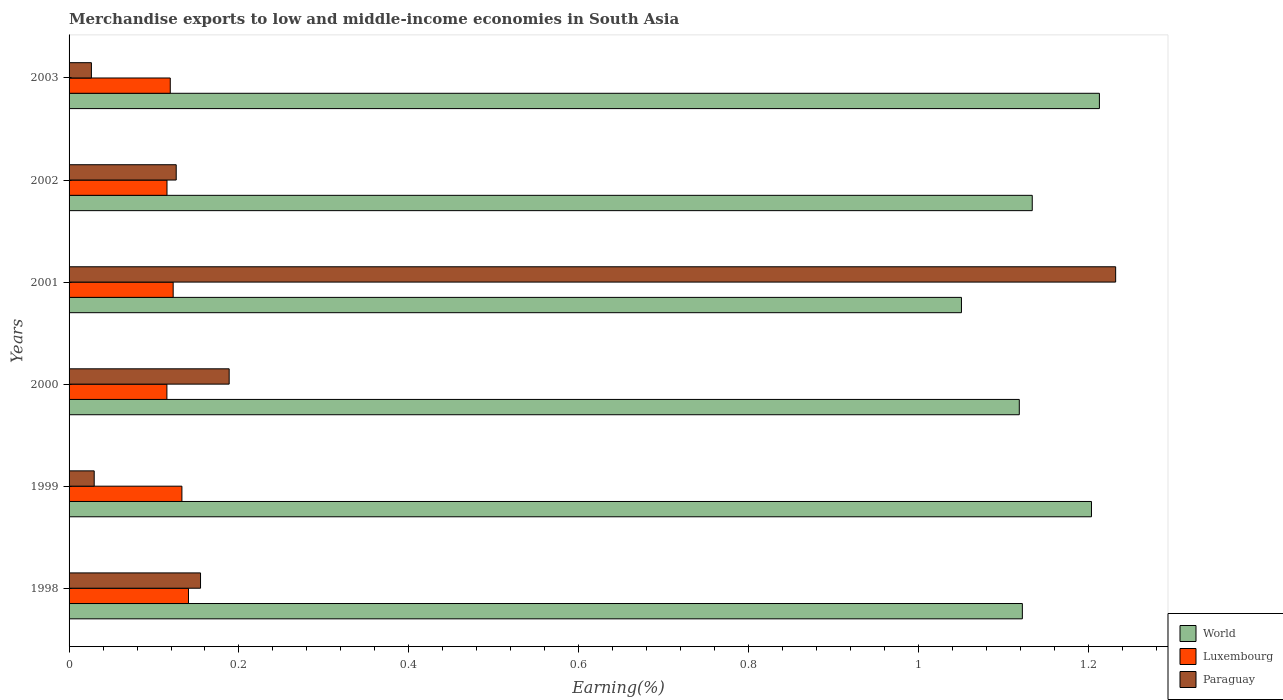How many different coloured bars are there?
Make the answer very short. 3. What is the label of the 2nd group of bars from the top?
Ensure brevity in your answer.  2002. In how many cases, is the number of bars for a given year not equal to the number of legend labels?
Provide a succinct answer. 0. What is the percentage of amount earned from merchandise exports in Paraguay in 2000?
Ensure brevity in your answer.  0.19. Across all years, what is the maximum percentage of amount earned from merchandise exports in World?
Provide a short and direct response. 1.21. Across all years, what is the minimum percentage of amount earned from merchandise exports in Paraguay?
Your response must be concise. 0.03. What is the total percentage of amount earned from merchandise exports in World in the graph?
Ensure brevity in your answer.  6.84. What is the difference between the percentage of amount earned from merchandise exports in Paraguay in 2000 and that in 2002?
Provide a short and direct response. 0.06. What is the difference between the percentage of amount earned from merchandise exports in Luxembourg in 2000 and the percentage of amount earned from merchandise exports in Paraguay in 2001?
Provide a short and direct response. -1.12. What is the average percentage of amount earned from merchandise exports in Paraguay per year?
Offer a terse response. 0.29. In the year 2001, what is the difference between the percentage of amount earned from merchandise exports in Paraguay and percentage of amount earned from merchandise exports in World?
Give a very brief answer. 0.18. In how many years, is the percentage of amount earned from merchandise exports in Paraguay greater than 0.16 %?
Your answer should be very brief. 2. What is the ratio of the percentage of amount earned from merchandise exports in Paraguay in 2002 to that in 2003?
Your answer should be very brief. 4.8. Is the percentage of amount earned from merchandise exports in World in 2001 less than that in 2002?
Offer a terse response. Yes. Is the difference between the percentage of amount earned from merchandise exports in Paraguay in 1999 and 2003 greater than the difference between the percentage of amount earned from merchandise exports in World in 1999 and 2003?
Provide a short and direct response. Yes. What is the difference between the highest and the second highest percentage of amount earned from merchandise exports in World?
Provide a short and direct response. 0.01. What is the difference between the highest and the lowest percentage of amount earned from merchandise exports in World?
Your response must be concise. 0.16. What does the 3rd bar from the top in 2002 represents?
Offer a terse response. World. What does the 2nd bar from the bottom in 2002 represents?
Make the answer very short. Luxembourg. Is it the case that in every year, the sum of the percentage of amount earned from merchandise exports in Paraguay and percentage of amount earned from merchandise exports in Luxembourg is greater than the percentage of amount earned from merchandise exports in World?
Offer a terse response. No. How many bars are there?
Your answer should be very brief. 18. Are all the bars in the graph horizontal?
Ensure brevity in your answer.  Yes. What is the difference between two consecutive major ticks on the X-axis?
Provide a succinct answer. 0.2. Are the values on the major ticks of X-axis written in scientific E-notation?
Provide a succinct answer. No. Where does the legend appear in the graph?
Your answer should be compact. Bottom right. What is the title of the graph?
Offer a terse response. Merchandise exports to low and middle-income economies in South Asia. Does "Saudi Arabia" appear as one of the legend labels in the graph?
Offer a terse response. No. What is the label or title of the X-axis?
Keep it short and to the point. Earning(%). What is the Earning(%) in World in 1998?
Provide a short and direct response. 1.12. What is the Earning(%) of Luxembourg in 1998?
Your response must be concise. 0.14. What is the Earning(%) of Paraguay in 1998?
Make the answer very short. 0.15. What is the Earning(%) in World in 1999?
Offer a very short reply. 1.2. What is the Earning(%) in Luxembourg in 1999?
Offer a terse response. 0.13. What is the Earning(%) of Paraguay in 1999?
Provide a succinct answer. 0.03. What is the Earning(%) in World in 2000?
Make the answer very short. 1.12. What is the Earning(%) in Luxembourg in 2000?
Ensure brevity in your answer.  0.12. What is the Earning(%) in Paraguay in 2000?
Give a very brief answer. 0.19. What is the Earning(%) in World in 2001?
Your answer should be compact. 1.05. What is the Earning(%) in Luxembourg in 2001?
Give a very brief answer. 0.12. What is the Earning(%) in Paraguay in 2001?
Your answer should be very brief. 1.23. What is the Earning(%) in World in 2002?
Keep it short and to the point. 1.13. What is the Earning(%) of Luxembourg in 2002?
Provide a succinct answer. 0.12. What is the Earning(%) in Paraguay in 2002?
Provide a succinct answer. 0.13. What is the Earning(%) of World in 2003?
Make the answer very short. 1.21. What is the Earning(%) in Luxembourg in 2003?
Keep it short and to the point. 0.12. What is the Earning(%) in Paraguay in 2003?
Ensure brevity in your answer.  0.03. Across all years, what is the maximum Earning(%) of World?
Keep it short and to the point. 1.21. Across all years, what is the maximum Earning(%) in Luxembourg?
Provide a succinct answer. 0.14. Across all years, what is the maximum Earning(%) in Paraguay?
Ensure brevity in your answer.  1.23. Across all years, what is the minimum Earning(%) of World?
Your answer should be very brief. 1.05. Across all years, what is the minimum Earning(%) in Luxembourg?
Make the answer very short. 0.12. Across all years, what is the minimum Earning(%) of Paraguay?
Your response must be concise. 0.03. What is the total Earning(%) of World in the graph?
Offer a terse response. 6.84. What is the total Earning(%) of Luxembourg in the graph?
Your answer should be compact. 0.75. What is the total Earning(%) of Paraguay in the graph?
Provide a short and direct response. 1.76. What is the difference between the Earning(%) in World in 1998 and that in 1999?
Your answer should be very brief. -0.08. What is the difference between the Earning(%) in Luxembourg in 1998 and that in 1999?
Offer a very short reply. 0.01. What is the difference between the Earning(%) in Paraguay in 1998 and that in 1999?
Keep it short and to the point. 0.13. What is the difference between the Earning(%) of World in 1998 and that in 2000?
Your answer should be very brief. 0. What is the difference between the Earning(%) of Luxembourg in 1998 and that in 2000?
Your answer should be very brief. 0.03. What is the difference between the Earning(%) of Paraguay in 1998 and that in 2000?
Give a very brief answer. -0.03. What is the difference between the Earning(%) in World in 1998 and that in 2001?
Make the answer very short. 0.07. What is the difference between the Earning(%) of Luxembourg in 1998 and that in 2001?
Provide a short and direct response. 0.02. What is the difference between the Earning(%) in Paraguay in 1998 and that in 2001?
Provide a short and direct response. -1.08. What is the difference between the Earning(%) in World in 1998 and that in 2002?
Your response must be concise. -0.01. What is the difference between the Earning(%) in Luxembourg in 1998 and that in 2002?
Provide a succinct answer. 0.03. What is the difference between the Earning(%) of Paraguay in 1998 and that in 2002?
Offer a terse response. 0.03. What is the difference between the Earning(%) of World in 1998 and that in 2003?
Keep it short and to the point. -0.09. What is the difference between the Earning(%) in Luxembourg in 1998 and that in 2003?
Provide a succinct answer. 0.02. What is the difference between the Earning(%) in Paraguay in 1998 and that in 2003?
Offer a very short reply. 0.13. What is the difference between the Earning(%) in World in 1999 and that in 2000?
Give a very brief answer. 0.08. What is the difference between the Earning(%) of Luxembourg in 1999 and that in 2000?
Ensure brevity in your answer.  0.02. What is the difference between the Earning(%) of Paraguay in 1999 and that in 2000?
Ensure brevity in your answer.  -0.16. What is the difference between the Earning(%) in World in 1999 and that in 2001?
Give a very brief answer. 0.15. What is the difference between the Earning(%) of Luxembourg in 1999 and that in 2001?
Make the answer very short. 0.01. What is the difference between the Earning(%) in Paraguay in 1999 and that in 2001?
Your answer should be very brief. -1.2. What is the difference between the Earning(%) in World in 1999 and that in 2002?
Offer a terse response. 0.07. What is the difference between the Earning(%) in Luxembourg in 1999 and that in 2002?
Provide a succinct answer. 0.02. What is the difference between the Earning(%) in Paraguay in 1999 and that in 2002?
Provide a succinct answer. -0.1. What is the difference between the Earning(%) of World in 1999 and that in 2003?
Give a very brief answer. -0.01. What is the difference between the Earning(%) in Luxembourg in 1999 and that in 2003?
Your answer should be compact. 0.01. What is the difference between the Earning(%) of Paraguay in 1999 and that in 2003?
Your answer should be compact. 0. What is the difference between the Earning(%) of World in 2000 and that in 2001?
Offer a terse response. 0.07. What is the difference between the Earning(%) in Luxembourg in 2000 and that in 2001?
Give a very brief answer. -0.01. What is the difference between the Earning(%) of Paraguay in 2000 and that in 2001?
Your answer should be compact. -1.04. What is the difference between the Earning(%) in World in 2000 and that in 2002?
Offer a very short reply. -0.02. What is the difference between the Earning(%) of Luxembourg in 2000 and that in 2002?
Ensure brevity in your answer.  -0. What is the difference between the Earning(%) of Paraguay in 2000 and that in 2002?
Your answer should be compact. 0.06. What is the difference between the Earning(%) of World in 2000 and that in 2003?
Provide a short and direct response. -0.09. What is the difference between the Earning(%) of Luxembourg in 2000 and that in 2003?
Offer a very short reply. -0. What is the difference between the Earning(%) in Paraguay in 2000 and that in 2003?
Provide a short and direct response. 0.16. What is the difference between the Earning(%) of World in 2001 and that in 2002?
Your answer should be compact. -0.08. What is the difference between the Earning(%) of Luxembourg in 2001 and that in 2002?
Ensure brevity in your answer.  0.01. What is the difference between the Earning(%) in Paraguay in 2001 and that in 2002?
Keep it short and to the point. 1.11. What is the difference between the Earning(%) of World in 2001 and that in 2003?
Provide a short and direct response. -0.16. What is the difference between the Earning(%) in Luxembourg in 2001 and that in 2003?
Keep it short and to the point. 0. What is the difference between the Earning(%) of Paraguay in 2001 and that in 2003?
Provide a succinct answer. 1.21. What is the difference between the Earning(%) of World in 2002 and that in 2003?
Ensure brevity in your answer.  -0.08. What is the difference between the Earning(%) in Luxembourg in 2002 and that in 2003?
Give a very brief answer. -0. What is the difference between the Earning(%) of Paraguay in 2002 and that in 2003?
Your response must be concise. 0.1. What is the difference between the Earning(%) in World in 1998 and the Earning(%) in Luxembourg in 1999?
Ensure brevity in your answer.  0.99. What is the difference between the Earning(%) of World in 1998 and the Earning(%) of Paraguay in 1999?
Provide a succinct answer. 1.09. What is the difference between the Earning(%) in Luxembourg in 1998 and the Earning(%) in Paraguay in 1999?
Your response must be concise. 0.11. What is the difference between the Earning(%) of World in 1998 and the Earning(%) of Paraguay in 2000?
Give a very brief answer. 0.93. What is the difference between the Earning(%) in Luxembourg in 1998 and the Earning(%) in Paraguay in 2000?
Offer a very short reply. -0.05. What is the difference between the Earning(%) of World in 1998 and the Earning(%) of Luxembourg in 2001?
Offer a very short reply. 1. What is the difference between the Earning(%) of World in 1998 and the Earning(%) of Paraguay in 2001?
Your answer should be compact. -0.11. What is the difference between the Earning(%) in Luxembourg in 1998 and the Earning(%) in Paraguay in 2001?
Provide a succinct answer. -1.09. What is the difference between the Earning(%) of World in 1998 and the Earning(%) of Luxembourg in 2002?
Ensure brevity in your answer.  1.01. What is the difference between the Earning(%) in Luxembourg in 1998 and the Earning(%) in Paraguay in 2002?
Make the answer very short. 0.01. What is the difference between the Earning(%) in World in 1998 and the Earning(%) in Luxembourg in 2003?
Provide a succinct answer. 1. What is the difference between the Earning(%) in World in 1998 and the Earning(%) in Paraguay in 2003?
Your answer should be very brief. 1.1. What is the difference between the Earning(%) in Luxembourg in 1998 and the Earning(%) in Paraguay in 2003?
Make the answer very short. 0.11. What is the difference between the Earning(%) in World in 1999 and the Earning(%) in Luxembourg in 2000?
Your answer should be very brief. 1.09. What is the difference between the Earning(%) of World in 1999 and the Earning(%) of Paraguay in 2000?
Provide a succinct answer. 1.02. What is the difference between the Earning(%) of Luxembourg in 1999 and the Earning(%) of Paraguay in 2000?
Make the answer very short. -0.06. What is the difference between the Earning(%) in World in 1999 and the Earning(%) in Luxembourg in 2001?
Your answer should be compact. 1.08. What is the difference between the Earning(%) in World in 1999 and the Earning(%) in Paraguay in 2001?
Keep it short and to the point. -0.03. What is the difference between the Earning(%) in Luxembourg in 1999 and the Earning(%) in Paraguay in 2001?
Keep it short and to the point. -1.1. What is the difference between the Earning(%) in World in 1999 and the Earning(%) in Luxembourg in 2002?
Make the answer very short. 1.09. What is the difference between the Earning(%) in World in 1999 and the Earning(%) in Paraguay in 2002?
Give a very brief answer. 1.08. What is the difference between the Earning(%) of Luxembourg in 1999 and the Earning(%) of Paraguay in 2002?
Your response must be concise. 0.01. What is the difference between the Earning(%) of World in 1999 and the Earning(%) of Luxembourg in 2003?
Provide a short and direct response. 1.08. What is the difference between the Earning(%) in World in 1999 and the Earning(%) in Paraguay in 2003?
Provide a succinct answer. 1.18. What is the difference between the Earning(%) in Luxembourg in 1999 and the Earning(%) in Paraguay in 2003?
Offer a very short reply. 0.11. What is the difference between the Earning(%) in World in 2000 and the Earning(%) in Luxembourg in 2001?
Ensure brevity in your answer.  1. What is the difference between the Earning(%) in World in 2000 and the Earning(%) in Paraguay in 2001?
Offer a terse response. -0.11. What is the difference between the Earning(%) of Luxembourg in 2000 and the Earning(%) of Paraguay in 2001?
Ensure brevity in your answer.  -1.12. What is the difference between the Earning(%) of World in 2000 and the Earning(%) of Luxembourg in 2002?
Provide a short and direct response. 1. What is the difference between the Earning(%) in Luxembourg in 2000 and the Earning(%) in Paraguay in 2002?
Ensure brevity in your answer.  -0.01. What is the difference between the Earning(%) in World in 2000 and the Earning(%) in Luxembourg in 2003?
Make the answer very short. 1. What is the difference between the Earning(%) of World in 2000 and the Earning(%) of Paraguay in 2003?
Your response must be concise. 1.09. What is the difference between the Earning(%) of Luxembourg in 2000 and the Earning(%) of Paraguay in 2003?
Make the answer very short. 0.09. What is the difference between the Earning(%) of World in 2001 and the Earning(%) of Luxembourg in 2002?
Your answer should be compact. 0.94. What is the difference between the Earning(%) of World in 2001 and the Earning(%) of Paraguay in 2002?
Make the answer very short. 0.92. What is the difference between the Earning(%) in Luxembourg in 2001 and the Earning(%) in Paraguay in 2002?
Your response must be concise. -0. What is the difference between the Earning(%) of World in 2001 and the Earning(%) of Luxembourg in 2003?
Give a very brief answer. 0.93. What is the difference between the Earning(%) of World in 2001 and the Earning(%) of Paraguay in 2003?
Ensure brevity in your answer.  1.02. What is the difference between the Earning(%) of Luxembourg in 2001 and the Earning(%) of Paraguay in 2003?
Give a very brief answer. 0.1. What is the difference between the Earning(%) in World in 2002 and the Earning(%) in Luxembourg in 2003?
Your response must be concise. 1.01. What is the difference between the Earning(%) in World in 2002 and the Earning(%) in Paraguay in 2003?
Your answer should be very brief. 1.11. What is the difference between the Earning(%) in Luxembourg in 2002 and the Earning(%) in Paraguay in 2003?
Your answer should be compact. 0.09. What is the average Earning(%) of World per year?
Keep it short and to the point. 1.14. What is the average Earning(%) in Luxembourg per year?
Provide a succinct answer. 0.12. What is the average Earning(%) in Paraguay per year?
Your answer should be compact. 0.29. In the year 1998, what is the difference between the Earning(%) in World and Earning(%) in Luxembourg?
Offer a terse response. 0.98. In the year 1998, what is the difference between the Earning(%) in World and Earning(%) in Paraguay?
Provide a short and direct response. 0.97. In the year 1998, what is the difference between the Earning(%) in Luxembourg and Earning(%) in Paraguay?
Provide a short and direct response. -0.01. In the year 1999, what is the difference between the Earning(%) of World and Earning(%) of Luxembourg?
Your answer should be very brief. 1.07. In the year 1999, what is the difference between the Earning(%) in World and Earning(%) in Paraguay?
Offer a very short reply. 1.17. In the year 1999, what is the difference between the Earning(%) in Luxembourg and Earning(%) in Paraguay?
Give a very brief answer. 0.1. In the year 2000, what is the difference between the Earning(%) in World and Earning(%) in Luxembourg?
Provide a succinct answer. 1. In the year 2000, what is the difference between the Earning(%) of World and Earning(%) of Paraguay?
Make the answer very short. 0.93. In the year 2000, what is the difference between the Earning(%) of Luxembourg and Earning(%) of Paraguay?
Your answer should be very brief. -0.07. In the year 2001, what is the difference between the Earning(%) in World and Earning(%) in Luxembourg?
Your answer should be very brief. 0.93. In the year 2001, what is the difference between the Earning(%) of World and Earning(%) of Paraguay?
Offer a very short reply. -0.18. In the year 2001, what is the difference between the Earning(%) in Luxembourg and Earning(%) in Paraguay?
Your answer should be very brief. -1.11. In the year 2002, what is the difference between the Earning(%) of World and Earning(%) of Luxembourg?
Offer a very short reply. 1.02. In the year 2002, what is the difference between the Earning(%) in World and Earning(%) in Paraguay?
Offer a very short reply. 1.01. In the year 2002, what is the difference between the Earning(%) of Luxembourg and Earning(%) of Paraguay?
Provide a succinct answer. -0.01. In the year 2003, what is the difference between the Earning(%) in World and Earning(%) in Luxembourg?
Provide a short and direct response. 1.09. In the year 2003, what is the difference between the Earning(%) in World and Earning(%) in Paraguay?
Offer a very short reply. 1.19. In the year 2003, what is the difference between the Earning(%) in Luxembourg and Earning(%) in Paraguay?
Your answer should be compact. 0.09. What is the ratio of the Earning(%) of World in 1998 to that in 1999?
Offer a terse response. 0.93. What is the ratio of the Earning(%) of Luxembourg in 1998 to that in 1999?
Your answer should be compact. 1.06. What is the ratio of the Earning(%) of Paraguay in 1998 to that in 1999?
Provide a short and direct response. 5.23. What is the ratio of the Earning(%) of Luxembourg in 1998 to that in 2000?
Provide a succinct answer. 1.22. What is the ratio of the Earning(%) of Paraguay in 1998 to that in 2000?
Provide a succinct answer. 0.82. What is the ratio of the Earning(%) in World in 1998 to that in 2001?
Your response must be concise. 1.07. What is the ratio of the Earning(%) in Luxembourg in 1998 to that in 2001?
Your response must be concise. 1.15. What is the ratio of the Earning(%) of Paraguay in 1998 to that in 2001?
Offer a very short reply. 0.13. What is the ratio of the Earning(%) of Luxembourg in 1998 to that in 2002?
Offer a very short reply. 1.22. What is the ratio of the Earning(%) in Paraguay in 1998 to that in 2002?
Your answer should be compact. 1.23. What is the ratio of the Earning(%) of World in 1998 to that in 2003?
Your answer should be very brief. 0.93. What is the ratio of the Earning(%) in Luxembourg in 1998 to that in 2003?
Give a very brief answer. 1.18. What is the ratio of the Earning(%) of Paraguay in 1998 to that in 2003?
Your answer should be compact. 5.89. What is the ratio of the Earning(%) of World in 1999 to that in 2000?
Your answer should be very brief. 1.08. What is the ratio of the Earning(%) in Luxembourg in 1999 to that in 2000?
Provide a short and direct response. 1.15. What is the ratio of the Earning(%) of Paraguay in 1999 to that in 2000?
Provide a succinct answer. 0.16. What is the ratio of the Earning(%) in World in 1999 to that in 2001?
Provide a short and direct response. 1.15. What is the ratio of the Earning(%) in Luxembourg in 1999 to that in 2001?
Give a very brief answer. 1.08. What is the ratio of the Earning(%) in Paraguay in 1999 to that in 2001?
Your answer should be very brief. 0.02. What is the ratio of the Earning(%) in World in 1999 to that in 2002?
Provide a succinct answer. 1.06. What is the ratio of the Earning(%) of Luxembourg in 1999 to that in 2002?
Offer a very short reply. 1.15. What is the ratio of the Earning(%) in Paraguay in 1999 to that in 2002?
Your answer should be very brief. 0.23. What is the ratio of the Earning(%) of World in 1999 to that in 2003?
Offer a terse response. 0.99. What is the ratio of the Earning(%) in Luxembourg in 1999 to that in 2003?
Your response must be concise. 1.11. What is the ratio of the Earning(%) in Paraguay in 1999 to that in 2003?
Your response must be concise. 1.13. What is the ratio of the Earning(%) of World in 2000 to that in 2001?
Offer a very short reply. 1.06. What is the ratio of the Earning(%) in Luxembourg in 2000 to that in 2001?
Your response must be concise. 0.94. What is the ratio of the Earning(%) in Paraguay in 2000 to that in 2001?
Give a very brief answer. 0.15. What is the ratio of the Earning(%) of World in 2000 to that in 2002?
Make the answer very short. 0.99. What is the ratio of the Earning(%) of Paraguay in 2000 to that in 2002?
Give a very brief answer. 1.49. What is the ratio of the Earning(%) of World in 2000 to that in 2003?
Provide a succinct answer. 0.92. What is the ratio of the Earning(%) in Luxembourg in 2000 to that in 2003?
Offer a terse response. 0.97. What is the ratio of the Earning(%) in Paraguay in 2000 to that in 2003?
Your response must be concise. 7.17. What is the ratio of the Earning(%) of World in 2001 to that in 2002?
Offer a very short reply. 0.93. What is the ratio of the Earning(%) in Luxembourg in 2001 to that in 2002?
Provide a succinct answer. 1.06. What is the ratio of the Earning(%) in Paraguay in 2001 to that in 2002?
Give a very brief answer. 9.77. What is the ratio of the Earning(%) of World in 2001 to that in 2003?
Keep it short and to the point. 0.87. What is the ratio of the Earning(%) of Luxembourg in 2001 to that in 2003?
Give a very brief answer. 1.03. What is the ratio of the Earning(%) in Paraguay in 2001 to that in 2003?
Make the answer very short. 46.87. What is the ratio of the Earning(%) of World in 2002 to that in 2003?
Offer a very short reply. 0.93. What is the ratio of the Earning(%) of Paraguay in 2002 to that in 2003?
Keep it short and to the point. 4.8. What is the difference between the highest and the second highest Earning(%) in World?
Provide a succinct answer. 0.01. What is the difference between the highest and the second highest Earning(%) in Luxembourg?
Your answer should be very brief. 0.01. What is the difference between the highest and the second highest Earning(%) of Paraguay?
Your answer should be very brief. 1.04. What is the difference between the highest and the lowest Earning(%) of World?
Offer a very short reply. 0.16. What is the difference between the highest and the lowest Earning(%) in Luxembourg?
Provide a succinct answer. 0.03. What is the difference between the highest and the lowest Earning(%) of Paraguay?
Keep it short and to the point. 1.21. 